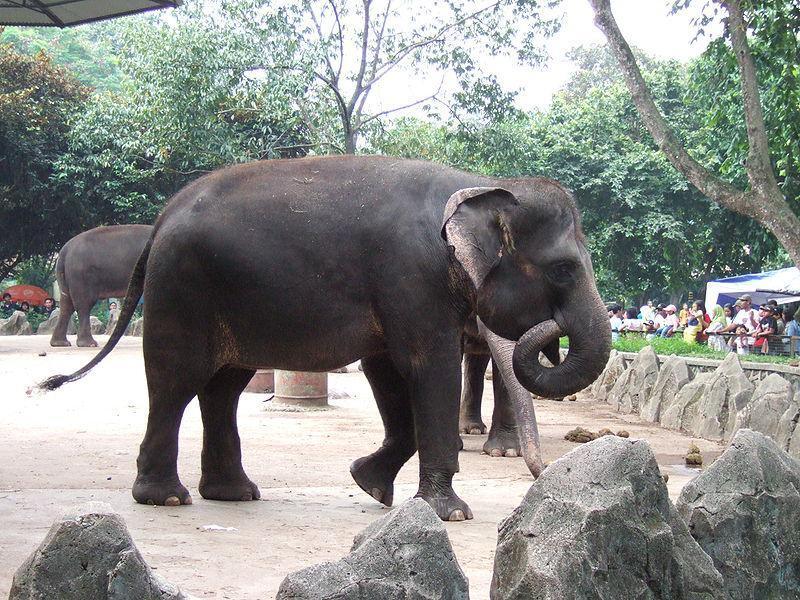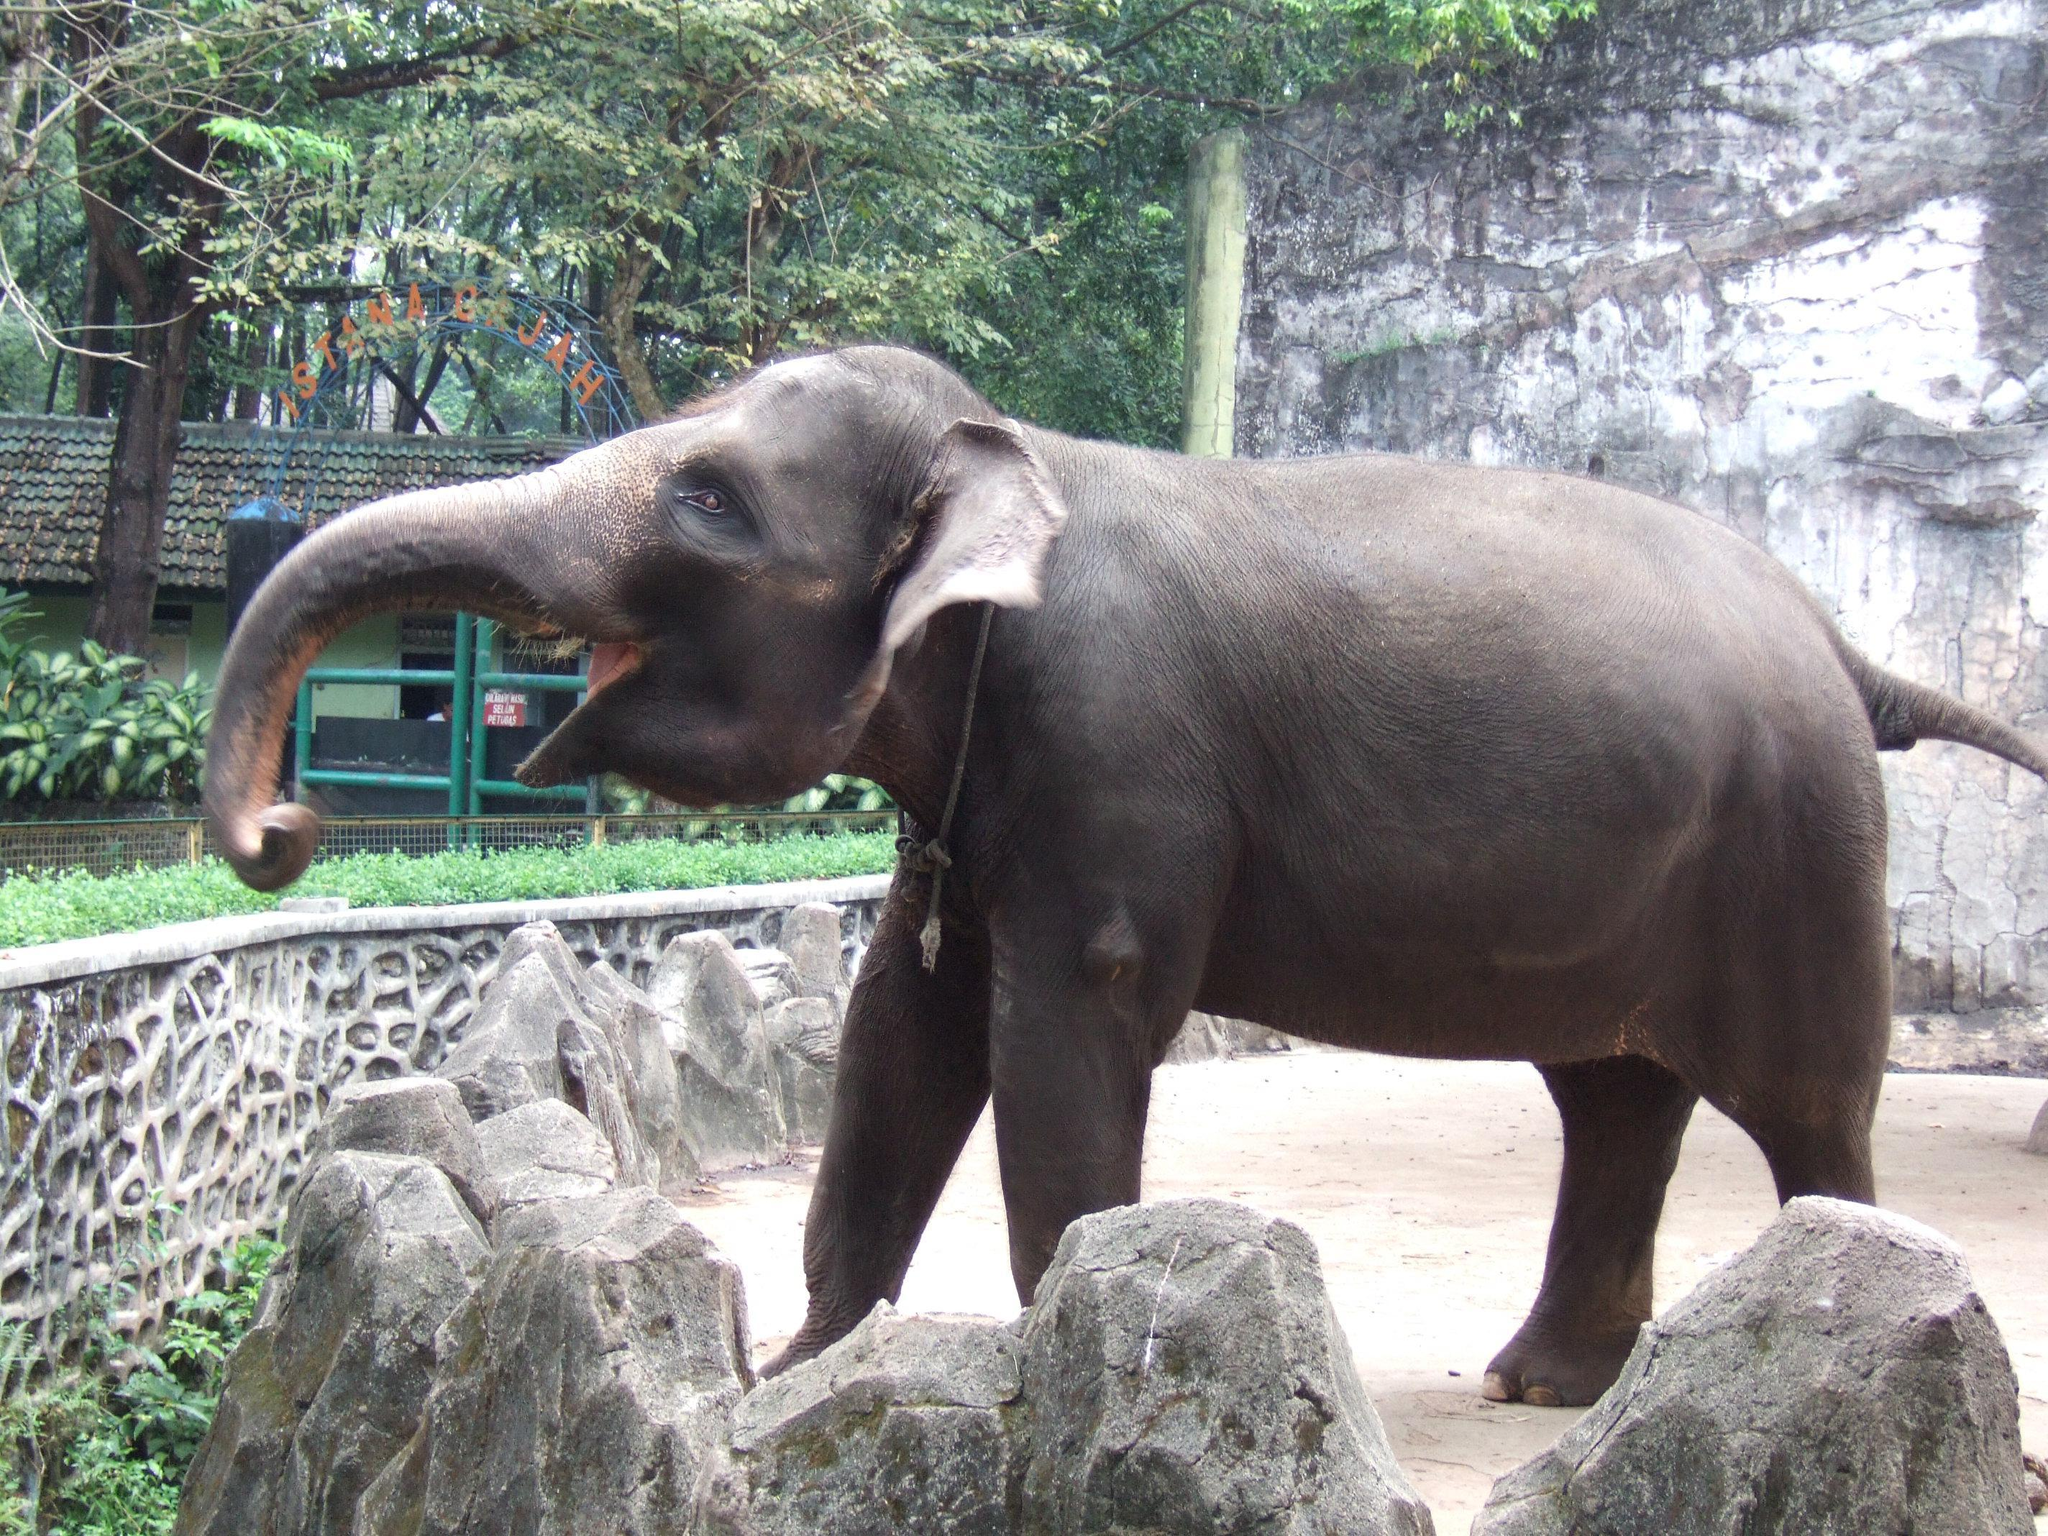The first image is the image on the left, the second image is the image on the right. Evaluate the accuracy of this statement regarding the images: "There are at leasts six elephants in one image.". Is it true? Answer yes or no. No. 